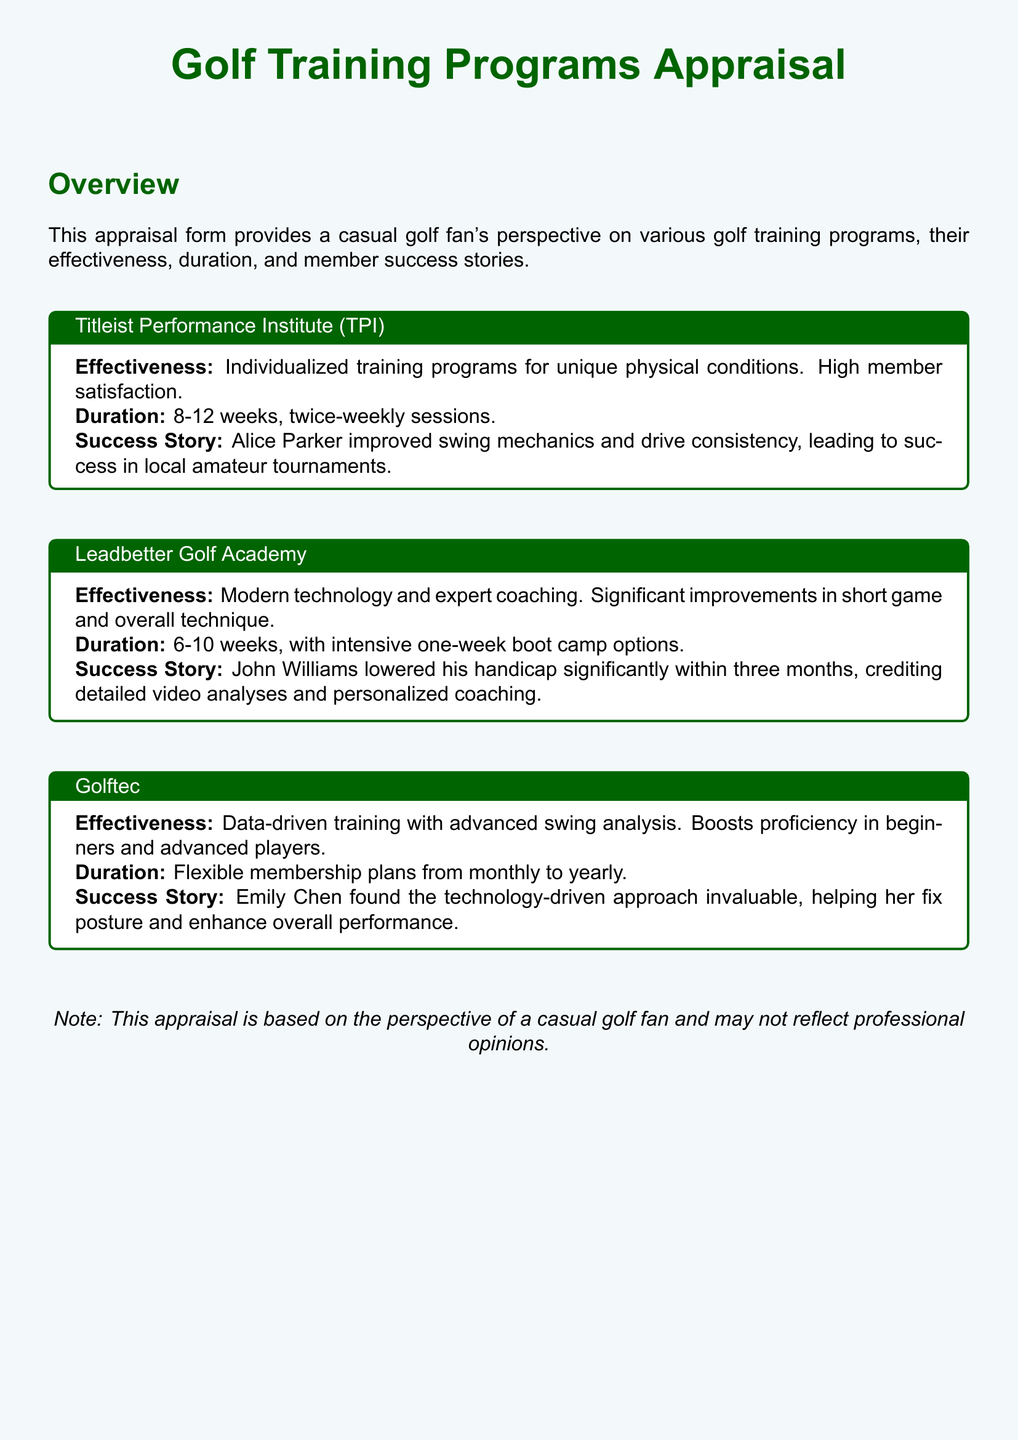What training program is highlighted in the title? The heading of the appraisal clearly states the focus on Golf Training Programs, providing an overview of different programs.
Answer: Golf Training Programs What is the duration of the Titleist Performance Institute program? The document specifies the duration of this program as 8-12 weeks with twice-weekly sessions.
Answer: 8-12 weeks Who improved their swing mechanics at TPI? The document mentions a specific success story of a member who notably improved their swing mechanics at the TPI program.
Answer: Alice Parker How long does the Leadbetter Golf Academy program last? The appraisal states that the duration of this program is 6-10 weeks, with the option of one-week intensive sessions.
Answer: 6-10 weeks What type of analysis does Golftec utilize? The appraisal indicates that Golftec uses advanced swing analysis as part of their data-driven training approach.
Answer: Swing analysis Which program had a member lower their handicap significantly? The success story provided under the Leadbetter Golf Academy highlights a member's achievement related to handicap reduction.
Answer: Leadbetter Golf Academy What is the effectiveness of the Golftec program? The document details the effectiveness of the Golftec program, emphasizing its data-driven approach and benefits for all skill levels.
Answer: Data-driven training What was the success of Emily Chen attributed to in the Golftec program? The appraisal states that her improved performance was linked to the technology-driven approach of Golftec.
Answer: Technology-driven approach What does the note at the end of the document clarify? The note emphasizes that the appraisal is based on a casual fan's perspective and may not reflect professional opinions.
Answer: Casual fan's perspective 